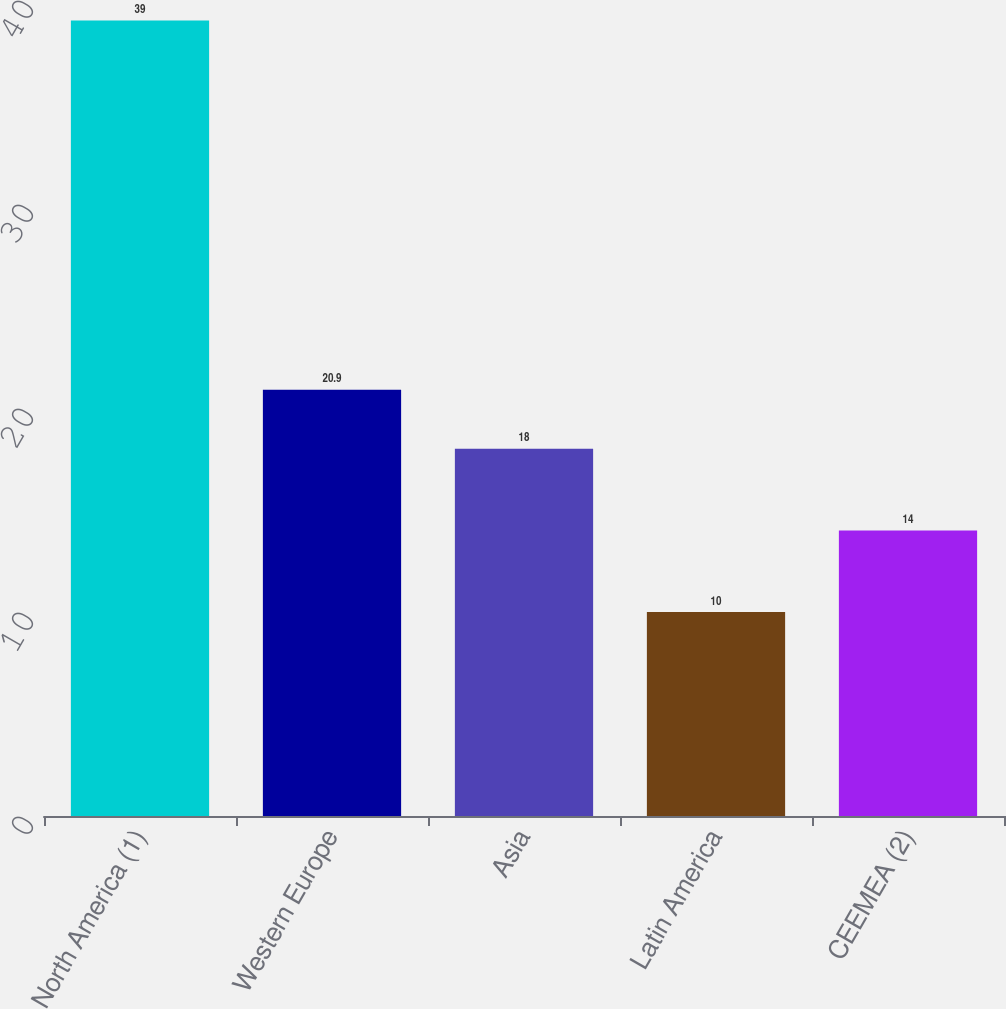Convert chart to OTSL. <chart><loc_0><loc_0><loc_500><loc_500><bar_chart><fcel>North America (1)<fcel>Western Europe<fcel>Asia<fcel>Latin America<fcel>CEEMEA (2)<nl><fcel>39<fcel>20.9<fcel>18<fcel>10<fcel>14<nl></chart> 